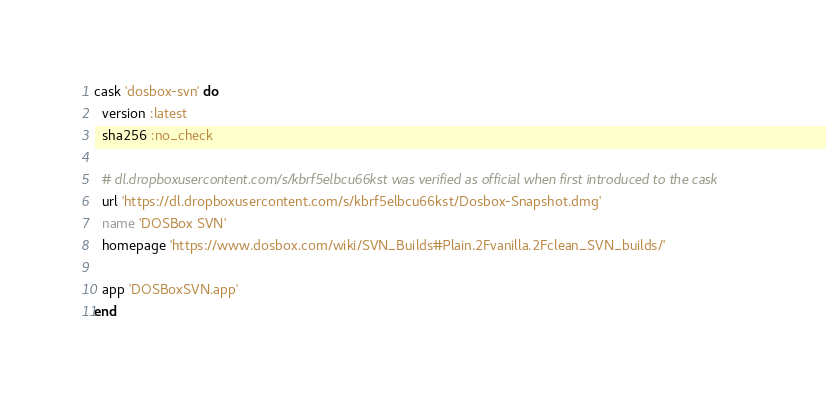<code> <loc_0><loc_0><loc_500><loc_500><_Ruby_>cask 'dosbox-svn' do
  version :latest
  sha256 :no_check

  # dl.dropboxusercontent.com/s/kbrf5elbcu66kst was verified as official when first introduced to the cask
  url 'https://dl.dropboxusercontent.com/s/kbrf5elbcu66kst/Dosbox-Snapshot.dmg'
  name 'DOSBox SVN'
  homepage 'https://www.dosbox.com/wiki/SVN_Builds#Plain.2Fvanilla.2Fclean_SVN_builds/'

  app 'DOSBoxSVN.app'
end
</code> 